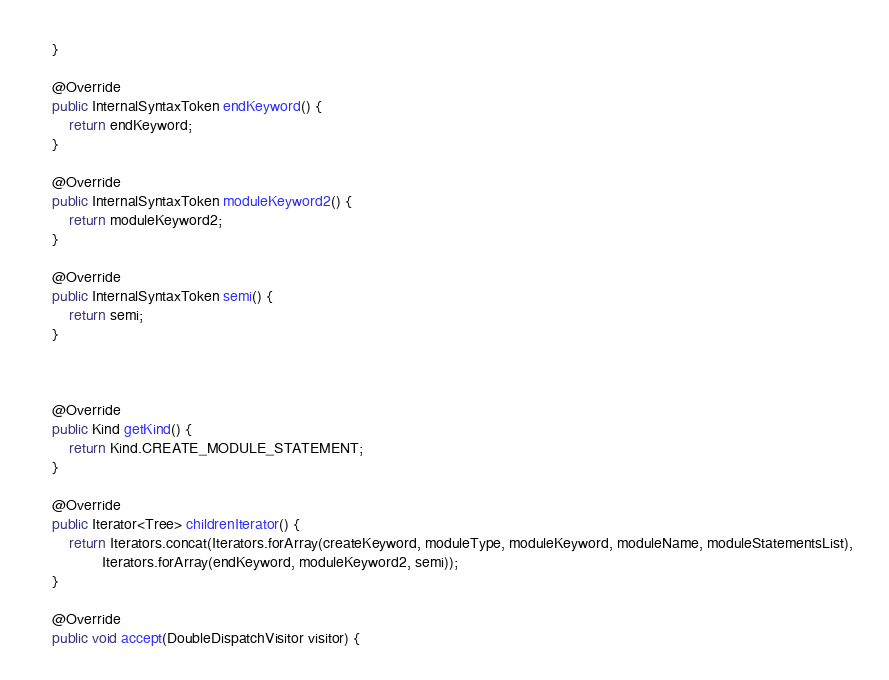Convert code to text. <code><loc_0><loc_0><loc_500><loc_500><_Java_>	}

	@Override
	public InternalSyntaxToken endKeyword() {
		return endKeyword;
	}

	@Override
	public InternalSyntaxToken moduleKeyword2() {
		return moduleKeyword2;
	}
	
	@Override
	public InternalSyntaxToken semi() {
		return semi;
	}
	
	

	@Override
	public Kind getKind() {
		return Kind.CREATE_MODULE_STATEMENT;
	}

	@Override
	public Iterator<Tree> childrenIterator() {
		return Iterators.concat(Iterators.forArray(createKeyword, moduleType, moduleKeyword, moduleName, moduleStatementsList),
				Iterators.forArray(endKeyword, moduleKeyword2, semi));
	}

	@Override
	public void accept(DoubleDispatchVisitor visitor) {</code> 